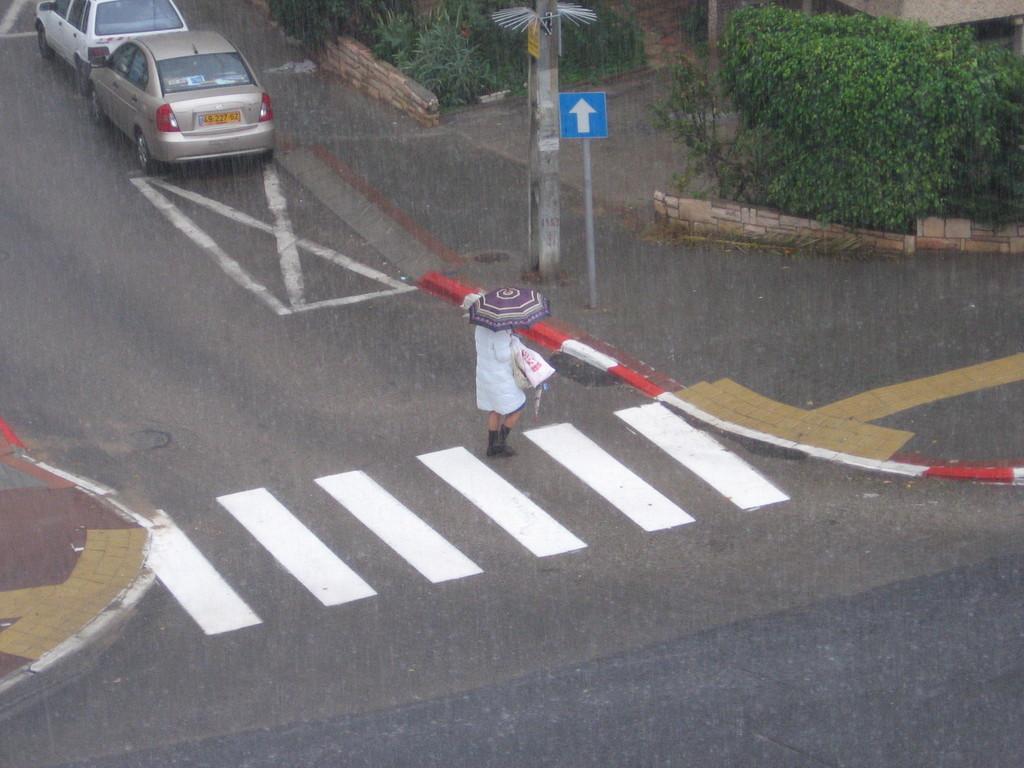In one or two sentences, can you explain what this image depicts? In the given image I can see a person holding umbrella, electric pole, plants, vehicle and road. 